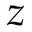Convert formula to latex. <formula><loc_0><loc_0><loc_500><loc_500>z</formula> 